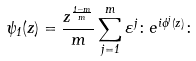Convert formula to latex. <formula><loc_0><loc_0><loc_500><loc_500>\psi _ { 1 } ( z ) = \frac { z ^ { \frac { 1 - m } { m } } } { m } \sum _ { j = 1 } ^ { m } \varepsilon ^ { j } \colon e ^ { i \phi ^ { j } ( z ) } \colon</formula> 